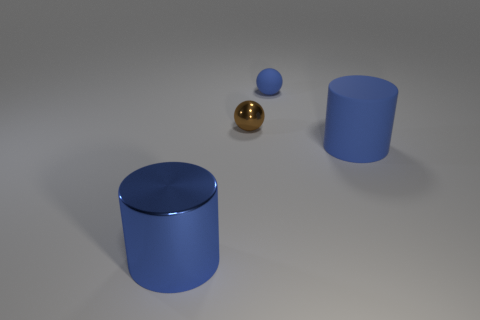Add 4 spheres. How many objects exist? 8 Subtract all gray metal objects. Subtract all small brown balls. How many objects are left? 3 Add 3 matte cylinders. How many matte cylinders are left? 4 Add 1 blue matte things. How many blue matte things exist? 3 Subtract 0 yellow spheres. How many objects are left? 4 